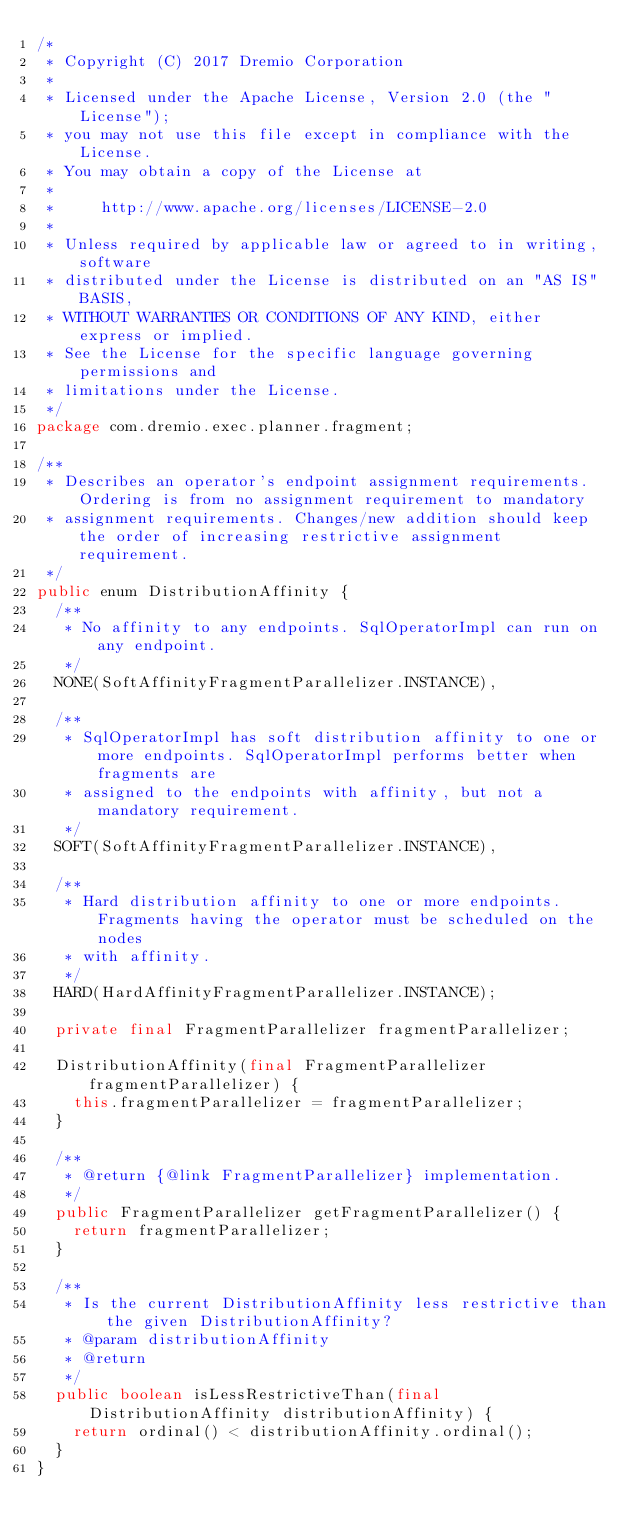<code> <loc_0><loc_0><loc_500><loc_500><_Java_>/*
 * Copyright (C) 2017 Dremio Corporation
 *
 * Licensed under the Apache License, Version 2.0 (the "License");
 * you may not use this file except in compliance with the License.
 * You may obtain a copy of the License at
 *
 *     http://www.apache.org/licenses/LICENSE-2.0
 *
 * Unless required by applicable law or agreed to in writing, software
 * distributed under the License is distributed on an "AS IS" BASIS,
 * WITHOUT WARRANTIES OR CONDITIONS OF ANY KIND, either express or implied.
 * See the License for the specific language governing permissions and
 * limitations under the License.
 */
package com.dremio.exec.planner.fragment;

/**
 * Describes an operator's endpoint assignment requirements. Ordering is from no assignment requirement to mandatory
 * assignment requirements. Changes/new addition should keep the order of increasing restrictive assignment requirement.
 */
public enum DistributionAffinity {
  /**
   * No affinity to any endpoints. SqlOperatorImpl can run on any endpoint.
   */
  NONE(SoftAffinityFragmentParallelizer.INSTANCE),

  /**
   * SqlOperatorImpl has soft distribution affinity to one or more endpoints. SqlOperatorImpl performs better when fragments are
   * assigned to the endpoints with affinity, but not a mandatory requirement.
   */
  SOFT(SoftAffinityFragmentParallelizer.INSTANCE),

  /**
   * Hard distribution affinity to one or more endpoints. Fragments having the operator must be scheduled on the nodes
   * with affinity.
   */
  HARD(HardAffinityFragmentParallelizer.INSTANCE);

  private final FragmentParallelizer fragmentParallelizer;

  DistributionAffinity(final FragmentParallelizer fragmentParallelizer) {
    this.fragmentParallelizer = fragmentParallelizer;
  }

  /**
   * @return {@link FragmentParallelizer} implementation.
   */
  public FragmentParallelizer getFragmentParallelizer() {
    return fragmentParallelizer;
  }

  /**
   * Is the current DistributionAffinity less restrictive than the given DistributionAffinity?
   * @param distributionAffinity
   * @return
   */
  public boolean isLessRestrictiveThan(final DistributionAffinity distributionAffinity) {
    return ordinal() < distributionAffinity.ordinal();
  }
}
</code> 